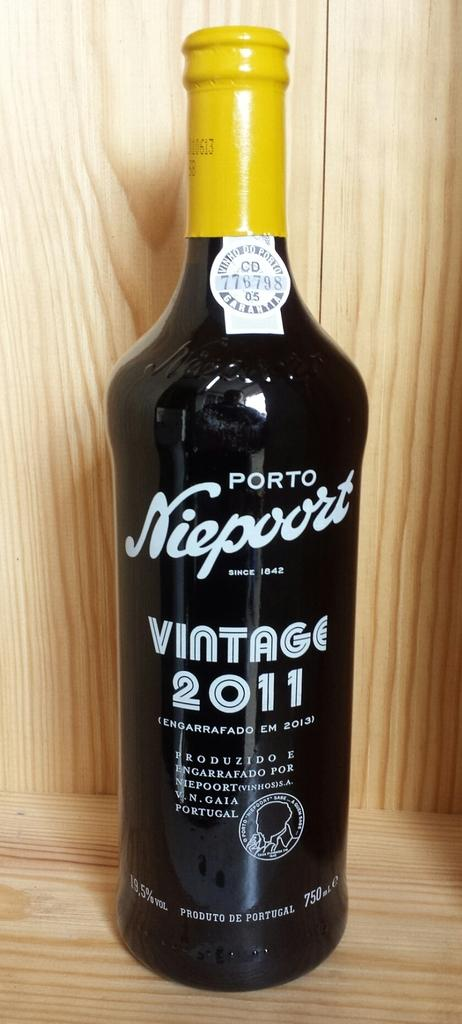<image>
Offer a succinct explanation of the picture presented. Black wine bottle that has the year 2011 on the front. 